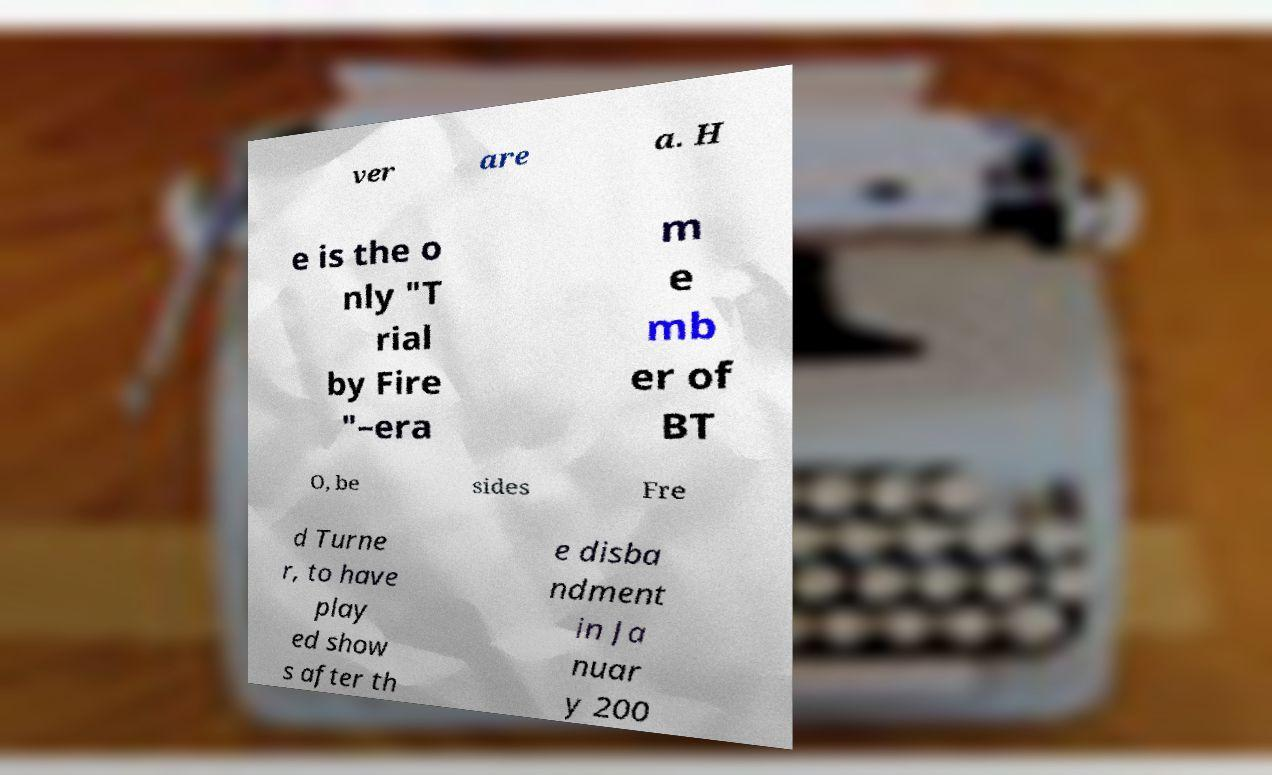Could you extract and type out the text from this image? ver are a. H e is the o nly "T rial by Fire "–era m e mb er of BT O, be sides Fre d Turne r, to have play ed show s after th e disba ndment in Ja nuar y 200 